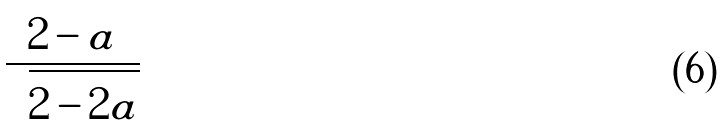<formula> <loc_0><loc_0><loc_500><loc_500>\frac { 2 - a } { \sqrt { 2 - 2 a } }</formula> 